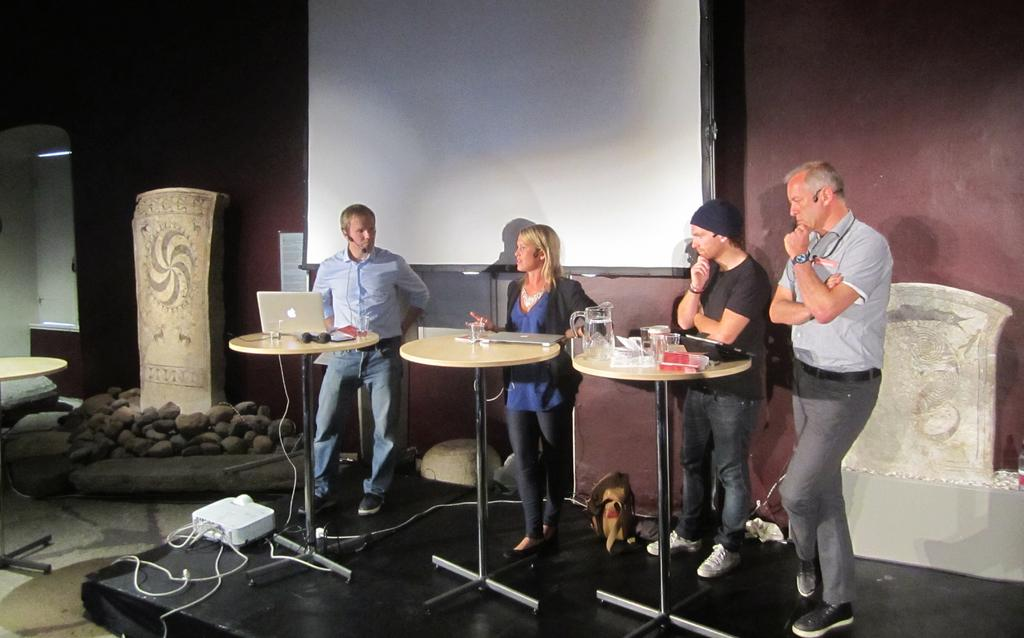How many people are in the image? There are three men and a woman standing in the image, making a total of four people. What electronic device is on the table? There is a laptop on the table. What other object is on the table? There is a jug on the table. What is the man in front of doing? The man in front is using a projector. What is in the background of the image? There is a screen and a wall in the background. What type of winter clothing can be seen on the woman in the image? There is no winter clothing visible in the image, as the people are not wearing any. What type of clouds can be seen in the image? There are no clouds visible in the image, as the background only shows a wall and a screen. 